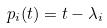Convert formula to latex. <formula><loc_0><loc_0><loc_500><loc_500>p _ { i } ( t ) = t - \lambda _ { i }</formula> 